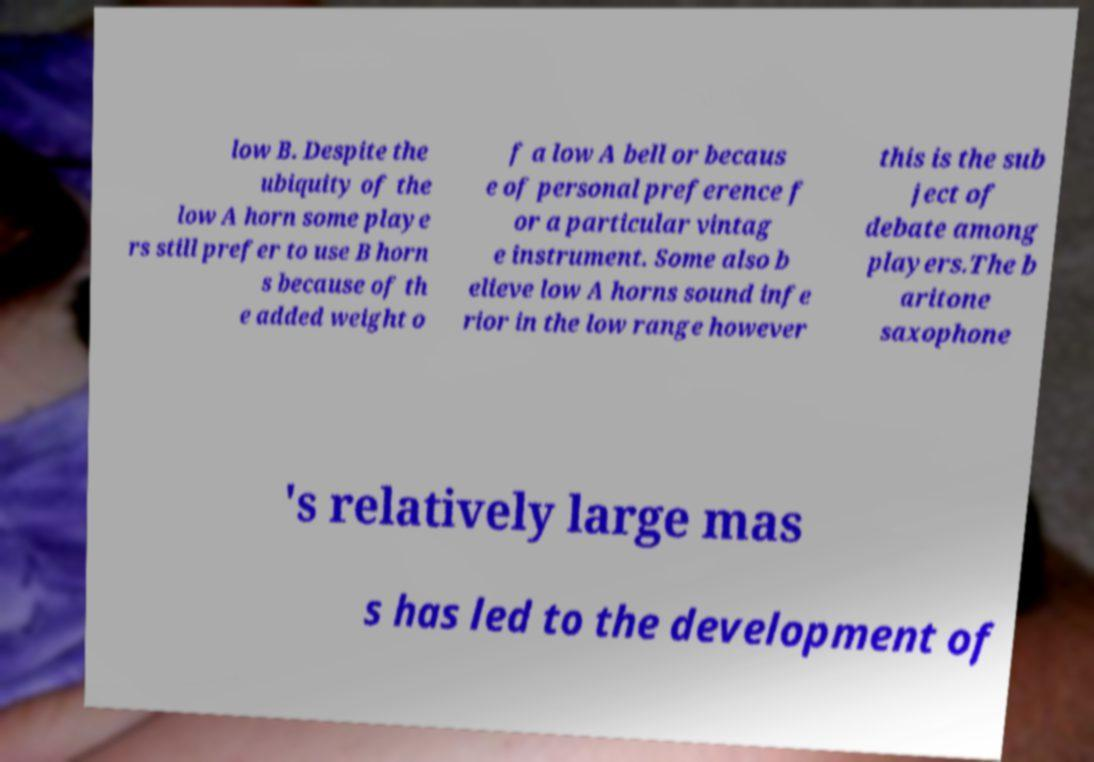There's text embedded in this image that I need extracted. Can you transcribe it verbatim? low B. Despite the ubiquity of the low A horn some playe rs still prefer to use B horn s because of th e added weight o f a low A bell or becaus e of personal preference f or a particular vintag e instrument. Some also b elieve low A horns sound infe rior in the low range however this is the sub ject of debate among players.The b aritone saxophone 's relatively large mas s has led to the development of 